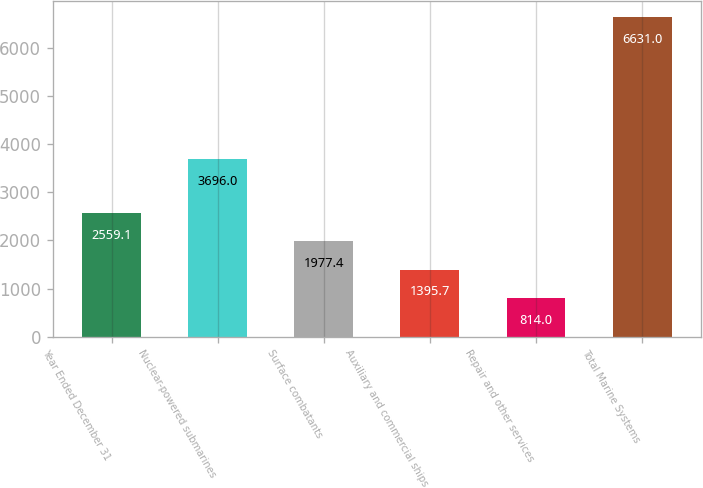<chart> <loc_0><loc_0><loc_500><loc_500><bar_chart><fcel>Year Ended December 31<fcel>Nuclear-powered submarines<fcel>Surface combatants<fcel>Auxiliary and commercial ships<fcel>Repair and other services<fcel>Total Marine Systems<nl><fcel>2559.1<fcel>3696<fcel>1977.4<fcel>1395.7<fcel>814<fcel>6631<nl></chart> 